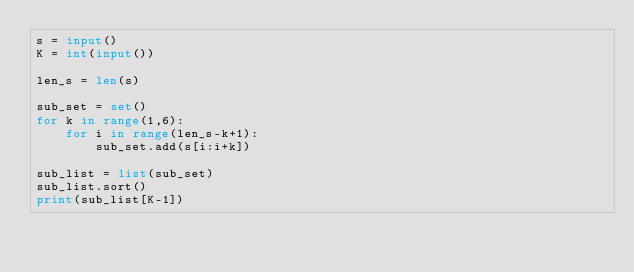Convert code to text. <code><loc_0><loc_0><loc_500><loc_500><_Python_>s = input()
K = int(input())

len_s = len(s)

sub_set = set()
for k in range(1,6):
    for i in range(len_s-k+1):
        sub_set.add(s[i:i+k])
        
sub_list = list(sub_set)
sub_list.sort()
print(sub_list[K-1])
        
        </code> 